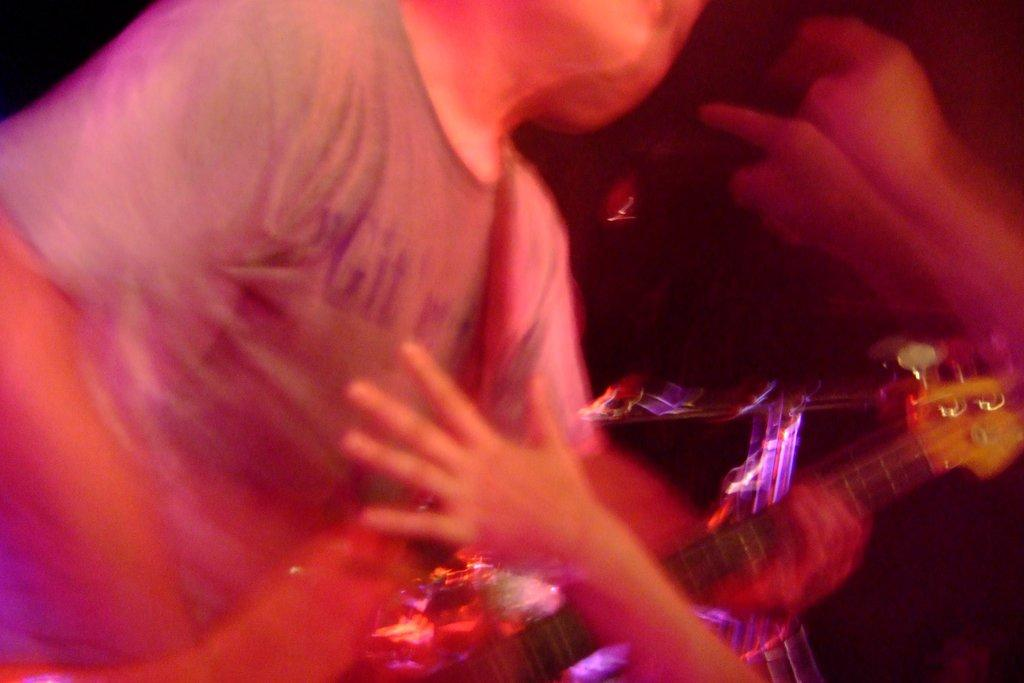What is the person on the left side of the image holding? The person on the left side of the image is holding a guitar. Can you describe the position of the person in the image? The person is on the left side of the image. What can be seen on the right side of the image? There are hands visible on the right side of the image. What type of feast is being prepared on the right side of the image? There is no feast or any indication of food preparation in the image; it only shows a person holding a guitar and hands on the right side. 